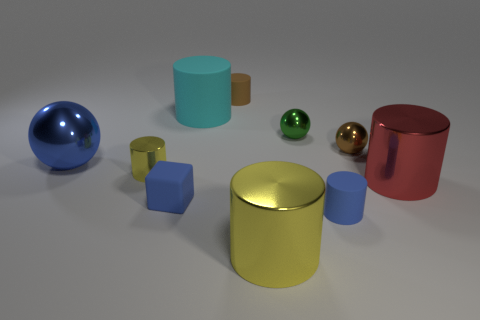Subtract all cyan cylinders. How many cylinders are left? 5 Subtract all cyan matte cylinders. How many cylinders are left? 5 Subtract all purple cylinders. Subtract all green cubes. How many cylinders are left? 6 Subtract all spheres. How many objects are left? 7 Subtract all blocks. Subtract all gray metal objects. How many objects are left? 9 Add 8 small balls. How many small balls are left? 10 Add 2 rubber cylinders. How many rubber cylinders exist? 5 Subtract 0 yellow blocks. How many objects are left? 10 